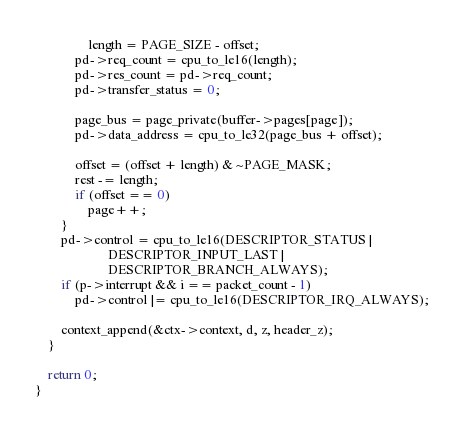Convert code to text. <code><loc_0><loc_0><loc_500><loc_500><_C_>				length = PAGE_SIZE - offset;
			pd->req_count = cpu_to_le16(length);
			pd->res_count = pd->req_count;
			pd->transfer_status = 0;

			page_bus = page_private(buffer->pages[page]);
			pd->data_address = cpu_to_le32(page_bus + offset);

			offset = (offset + length) & ~PAGE_MASK;
			rest -= length;
			if (offset == 0)
				page++;
		}
		pd->control = cpu_to_le16(DESCRIPTOR_STATUS |
					  DESCRIPTOR_INPUT_LAST |
					  DESCRIPTOR_BRANCH_ALWAYS);
		if (p->interrupt && i == packet_count - 1)
			pd->control |= cpu_to_le16(DESCRIPTOR_IRQ_ALWAYS);

		context_append(&ctx->context, d, z, header_z);
	}

	return 0;
}
</code> 